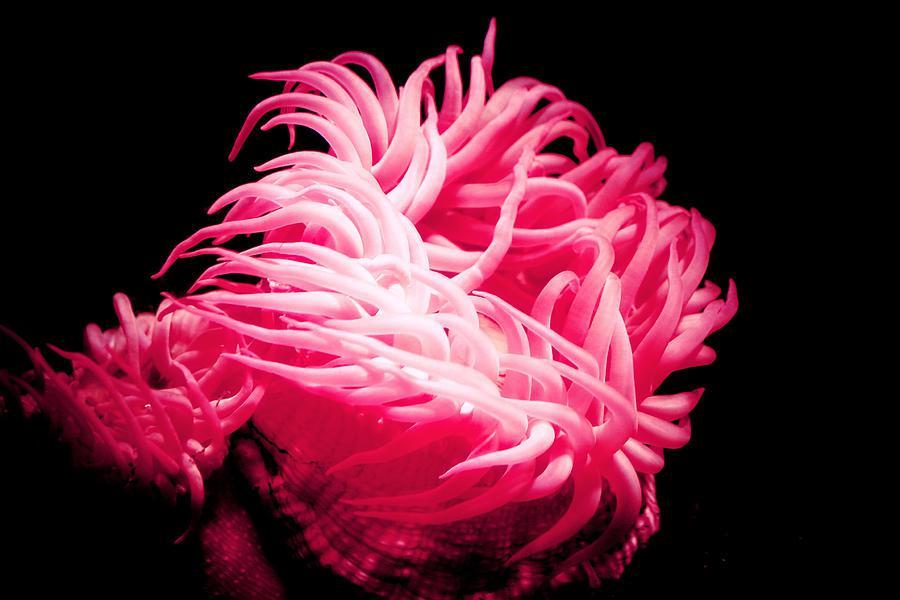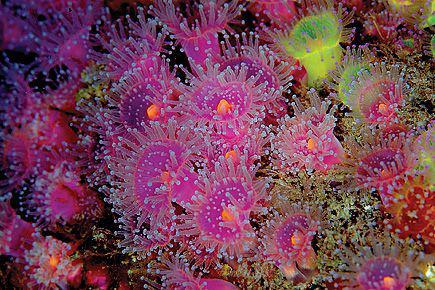The first image is the image on the left, the second image is the image on the right. Evaluate the accuracy of this statement regarding the images: "In there water there are at least 5 corral pieces with two tone colored arms.". Is it true? Answer yes or no. Yes. 